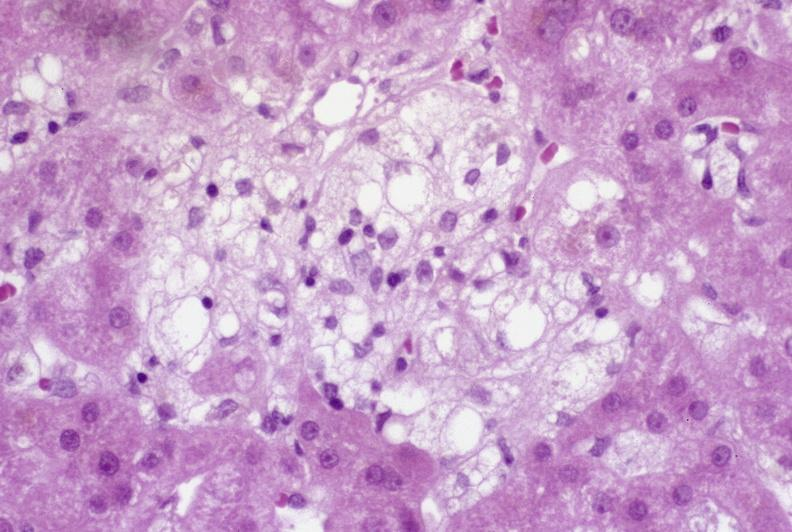what is present?
Answer the question using a single word or phrase. Liver 